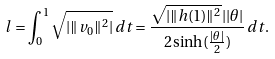<formula> <loc_0><loc_0><loc_500><loc_500>l = \int _ { 0 } ^ { 1 } \sqrt { | \| v _ { 0 } \| ^ { 2 } | } \, d t = \frac { \sqrt { | \| h ( 1 ) \| ^ { 2 } } | | \theta | } { 2 \sinh ( \frac { | \theta | } { 2 } ) } \, d t .</formula> 